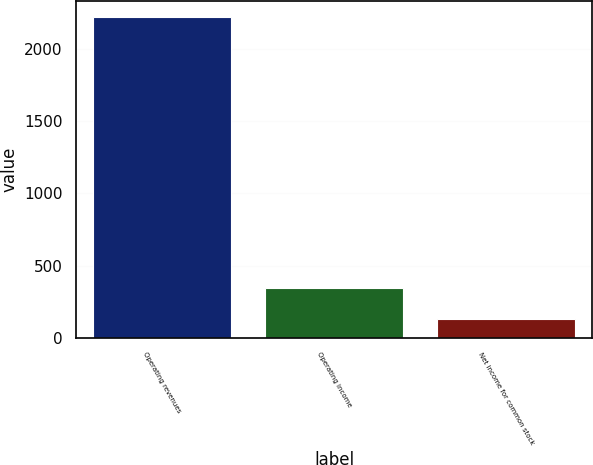<chart> <loc_0><loc_0><loc_500><loc_500><bar_chart><fcel>Operating revenues<fcel>Operating income<fcel>Net income for common stock<nl><fcel>2220<fcel>344.4<fcel>136<nl></chart> 